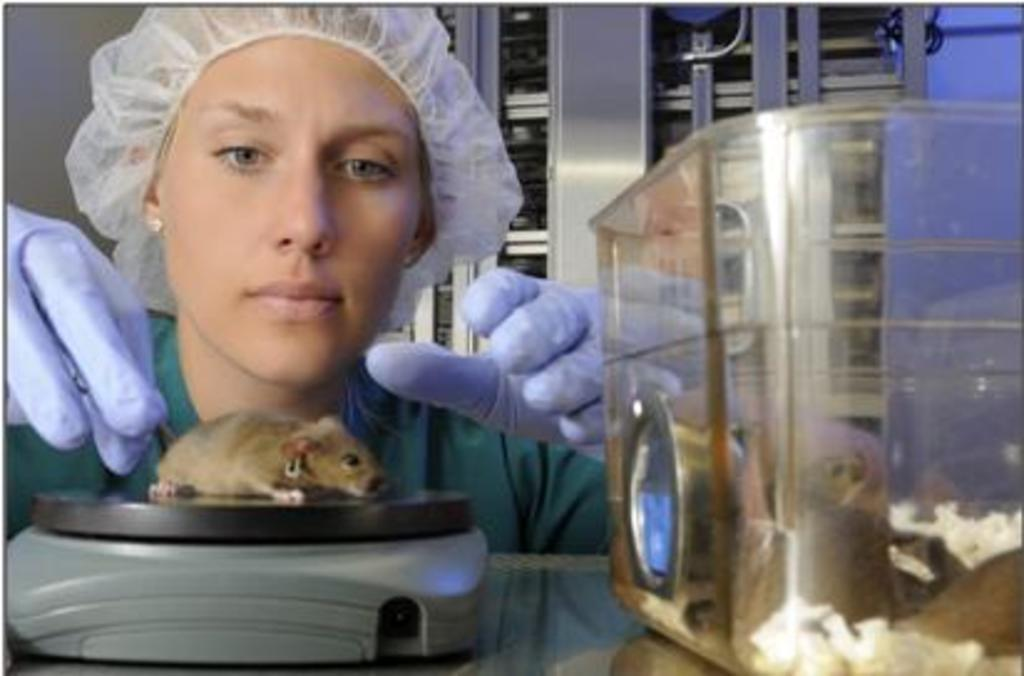What is the mouse interacting with in the image? There is a mouse on an object in the image. What can be seen in the foreground area of the image? There is a box in the foreground area of the image. Who is present behind the box in the image? There is a woman behind the box in the image. What is visible in the background of the image? There is an object in the background of the image. What type of bread is being advertised in the image? There is no bread or advertisement present in the image. What kind of trouble is the mouse causing in the image? The mouse is not causing any trouble in the image; it is simply on an object. 